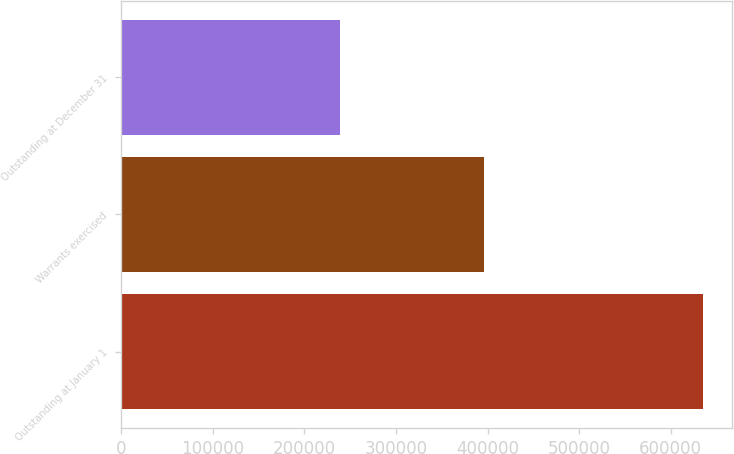Convert chart to OTSL. <chart><loc_0><loc_0><loc_500><loc_500><bar_chart><fcel>Outstanding at January 1<fcel>Warrants exercised<fcel>Outstanding at December 31<nl><fcel>634611<fcel>395908<fcel>238703<nl></chart> 